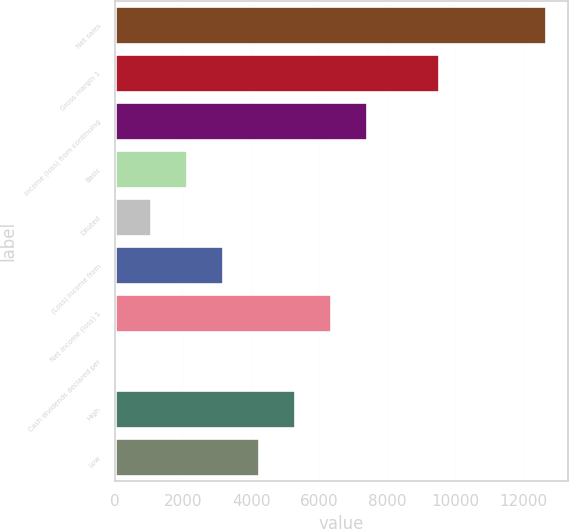Convert chart to OTSL. <chart><loc_0><loc_0><loc_500><loc_500><bar_chart><fcel>Net sales<fcel>Gross margin 1<fcel>Income (loss) from continuing<fcel>Basic<fcel>Diluted<fcel>(Loss) income from<fcel>Net income (loss) 1<fcel>Cash dividends declared per<fcel>High<fcel>Low<nl><fcel>12673.1<fcel>9504.97<fcel>7392.89<fcel>2112.69<fcel>1056.65<fcel>3168.73<fcel>6336.85<fcel>0.61<fcel>5280.81<fcel>4224.77<nl></chart> 